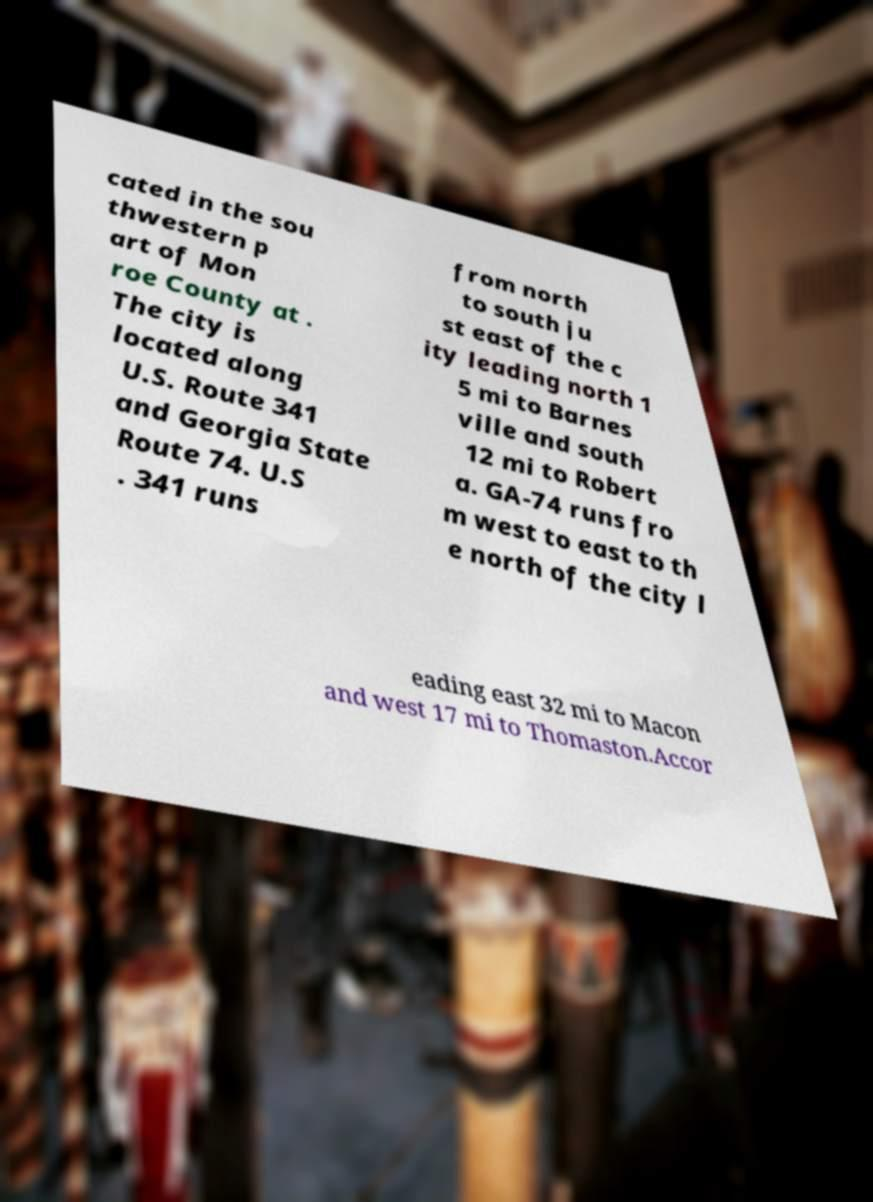Could you extract and type out the text from this image? cated in the sou thwestern p art of Mon roe County at . The city is located along U.S. Route 341 and Georgia State Route 74. U.S . 341 runs from north to south ju st east of the c ity leading north 1 5 mi to Barnes ville and south 12 mi to Robert a. GA-74 runs fro m west to east to th e north of the city l eading east 32 mi to Macon and west 17 mi to Thomaston.Accor 